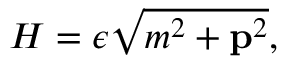Convert formula to latex. <formula><loc_0><loc_0><loc_500><loc_500>H = \epsilon \sqrt { m ^ { 2 } + { p } ^ { 2 } } ,</formula> 